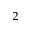<formula> <loc_0><loc_0><loc_500><loc_500>_ { 2 }</formula> 